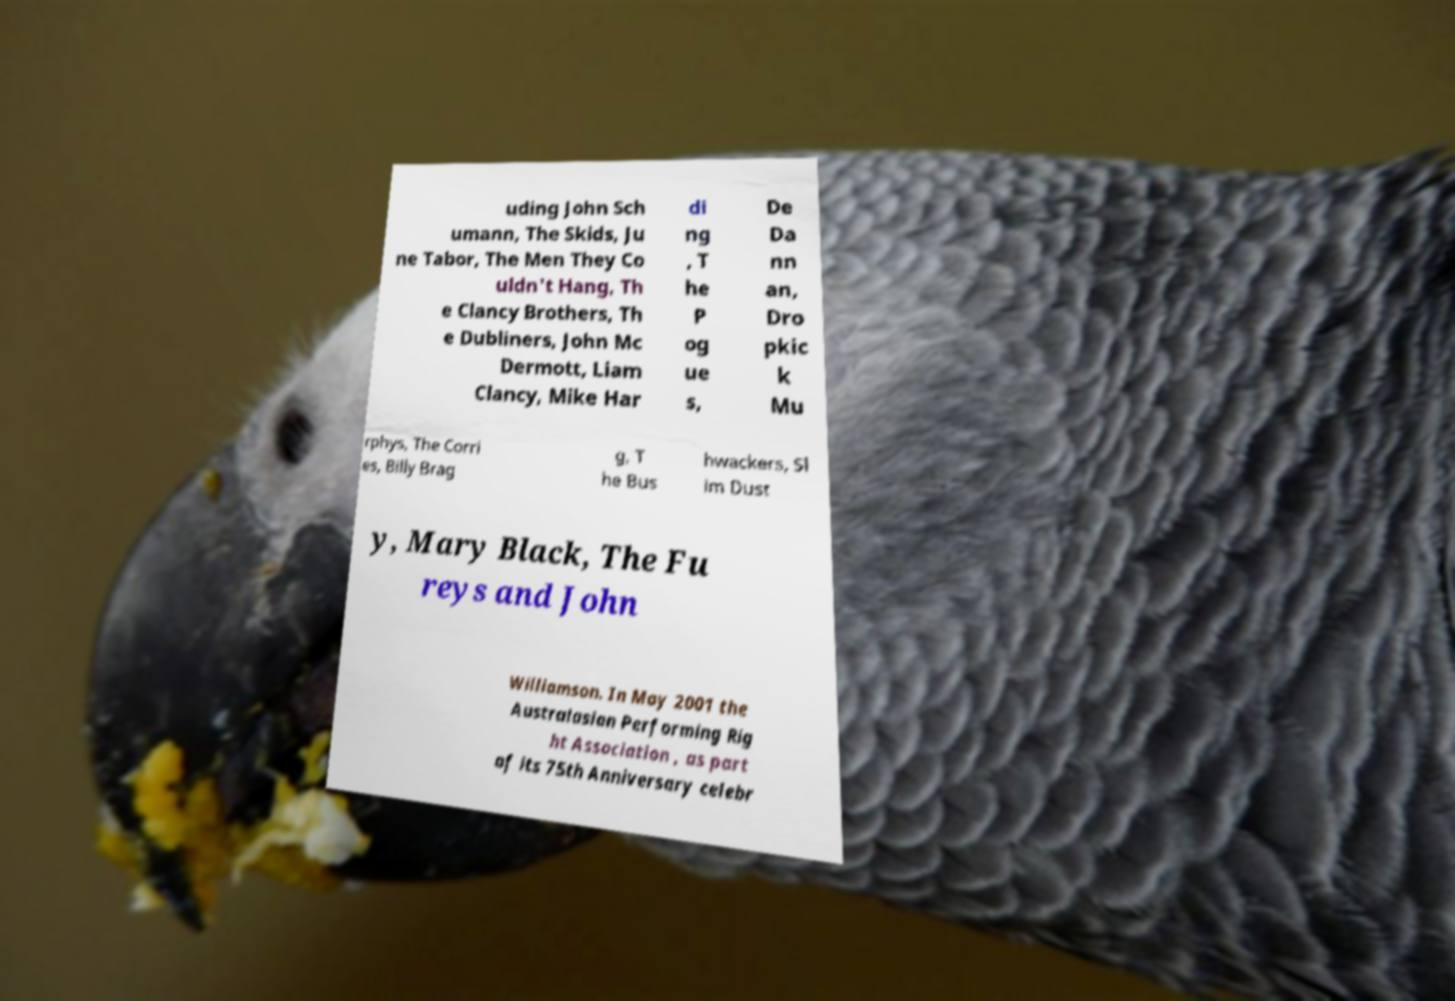What messages or text are displayed in this image? I need them in a readable, typed format. uding John Sch umann, The Skids, Ju ne Tabor, The Men They Co uldn't Hang, Th e Clancy Brothers, Th e Dubliners, John Mc Dermott, Liam Clancy, Mike Har di ng , T he P og ue s, De Da nn an, Dro pkic k Mu rphys, The Corri es, Billy Brag g, T he Bus hwackers, Sl im Dust y, Mary Black, The Fu reys and John Williamson. In May 2001 the Australasian Performing Rig ht Association , as part of its 75th Anniversary celebr 